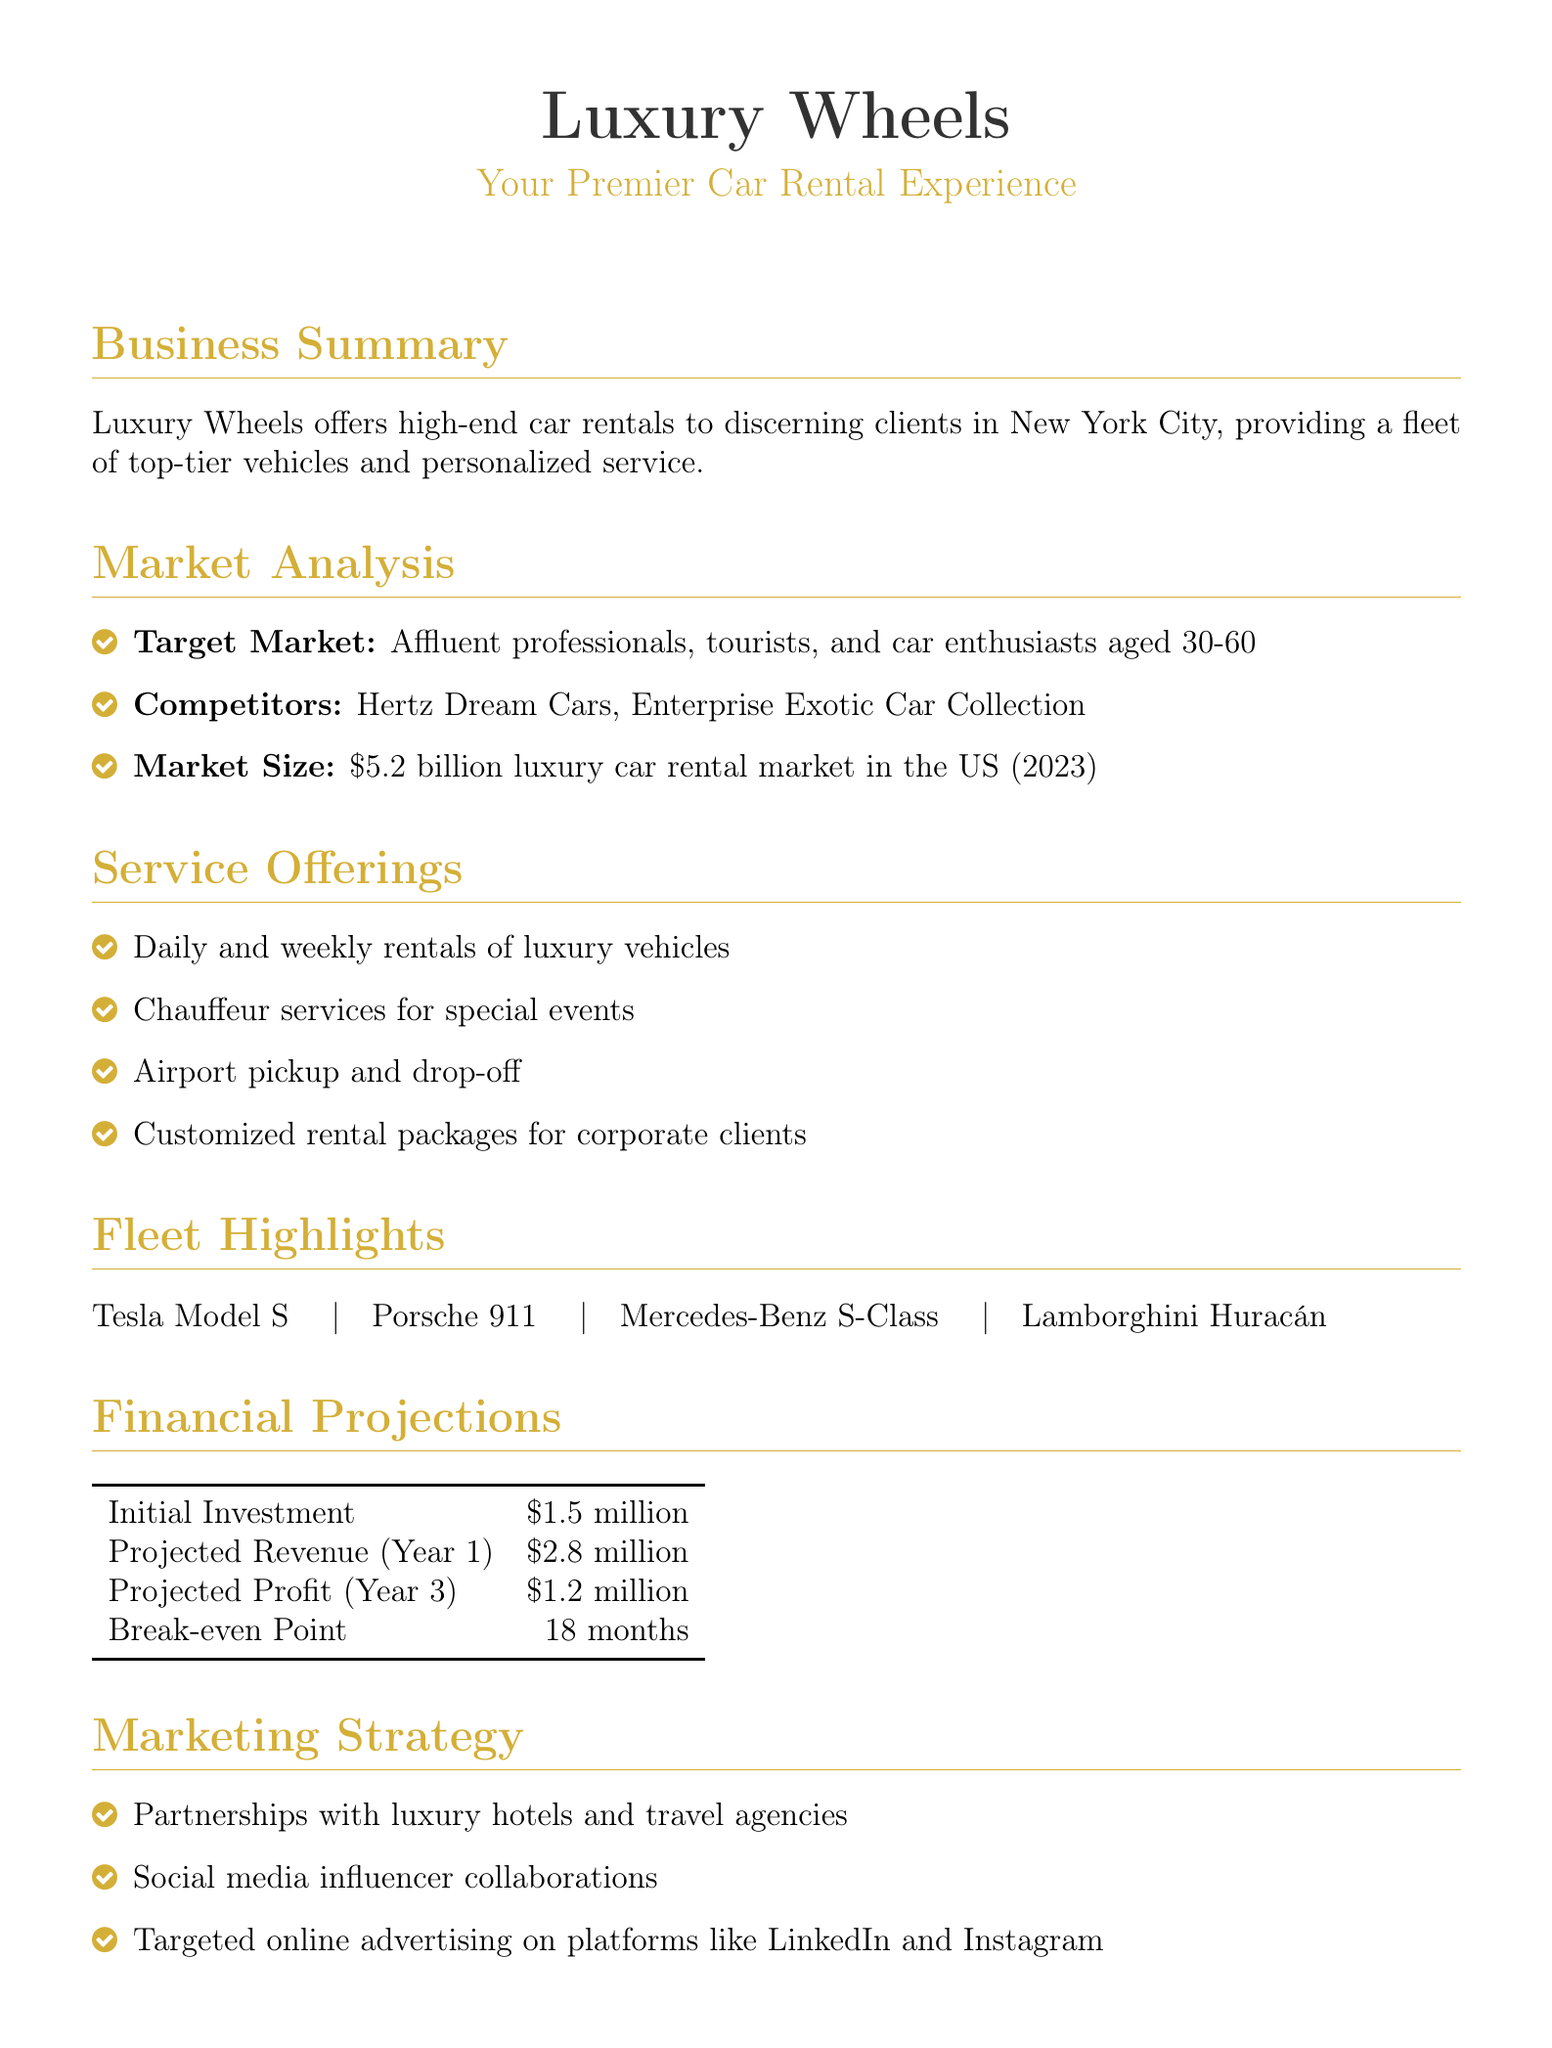What is the name of the business? The name of the business is the first piece of information presented in the document.
Answer: Luxury Wheels What is the initial investment amount? The initial investment amount is provided in the financial projections section of the document.
Answer: 1.5 million Who is the target market? The target market is mentioned in the market analysis part of the document, identifying the specific group of customers.
Answer: Affluent professionals, tourists, and car enthusiasts aged 30-60 What is the projected revenue for Year 1? The projected revenue for Year 1 is specifically listed in the financial projections section.
Answer: 2.8 million What are the fleet highlights? The fleet highlights are listed in a section and describe the types of vehicles available for rent.
Answer: Tesla Model S, Porsche 911, Mercedes-Benz S-Class, Lamborghini Huracán How long is the break-even point? The break-even point is a financial term mentioned in the projections to indicate when the business will start making a profit.
Answer: 18 months What marketing strategy is mentioned involving hotels? The document notes a specific initiative for attracting customers through a collaboration with a specific type of business.
Answer: Partnerships with luxury hotels What is a unique selling point of the service? Unique selling points are features that distinguish this service from competitors, listed in their own section.
Answer: 24/7 concierge service What is the projected profit for Year 3? The projected profit for Year 3 is included in the financial projections and signifies expected earnings.
Answer: 1.2 million 